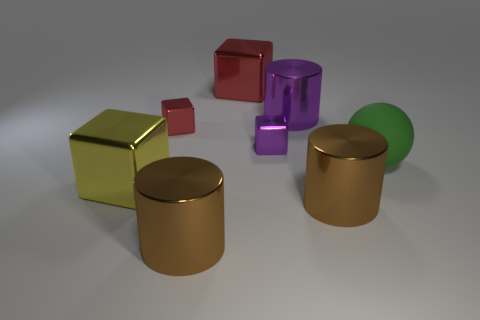How many objects are brown rubber blocks or objects that are on the left side of the green thing?
Offer a very short reply. 7. What is the object behind the big metallic cylinder that is behind the large matte object that is to the right of the large purple shiny thing made of?
Make the answer very short. Metal. Is there anything else that is the same material as the big green object?
Provide a short and direct response. No. How many red things are tiny metal objects or metal cylinders?
Make the answer very short. 1. How many other things are the same shape as the yellow object?
Ensure brevity in your answer.  3. Does the big red thing have the same material as the large green thing?
Keep it short and to the point. No. The large thing that is behind the yellow block and in front of the purple cube is made of what material?
Offer a terse response. Rubber. There is a large shiny block on the right side of the yellow metal block; what is its color?
Keep it short and to the point. Red. Are there more small metal cubes that are to the left of the purple metallic block than big green shiny cylinders?
Provide a short and direct response. Yes. How many other objects are there of the same size as the purple metal block?
Make the answer very short. 1. 